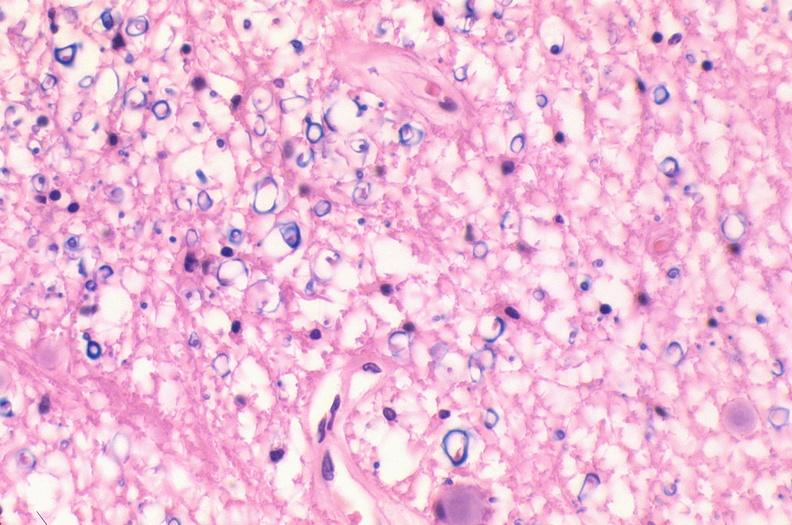does hepatobiliary show spinal cord injury due to vertebral column trauma, demyelination?
Answer the question using a single word or phrase. No 